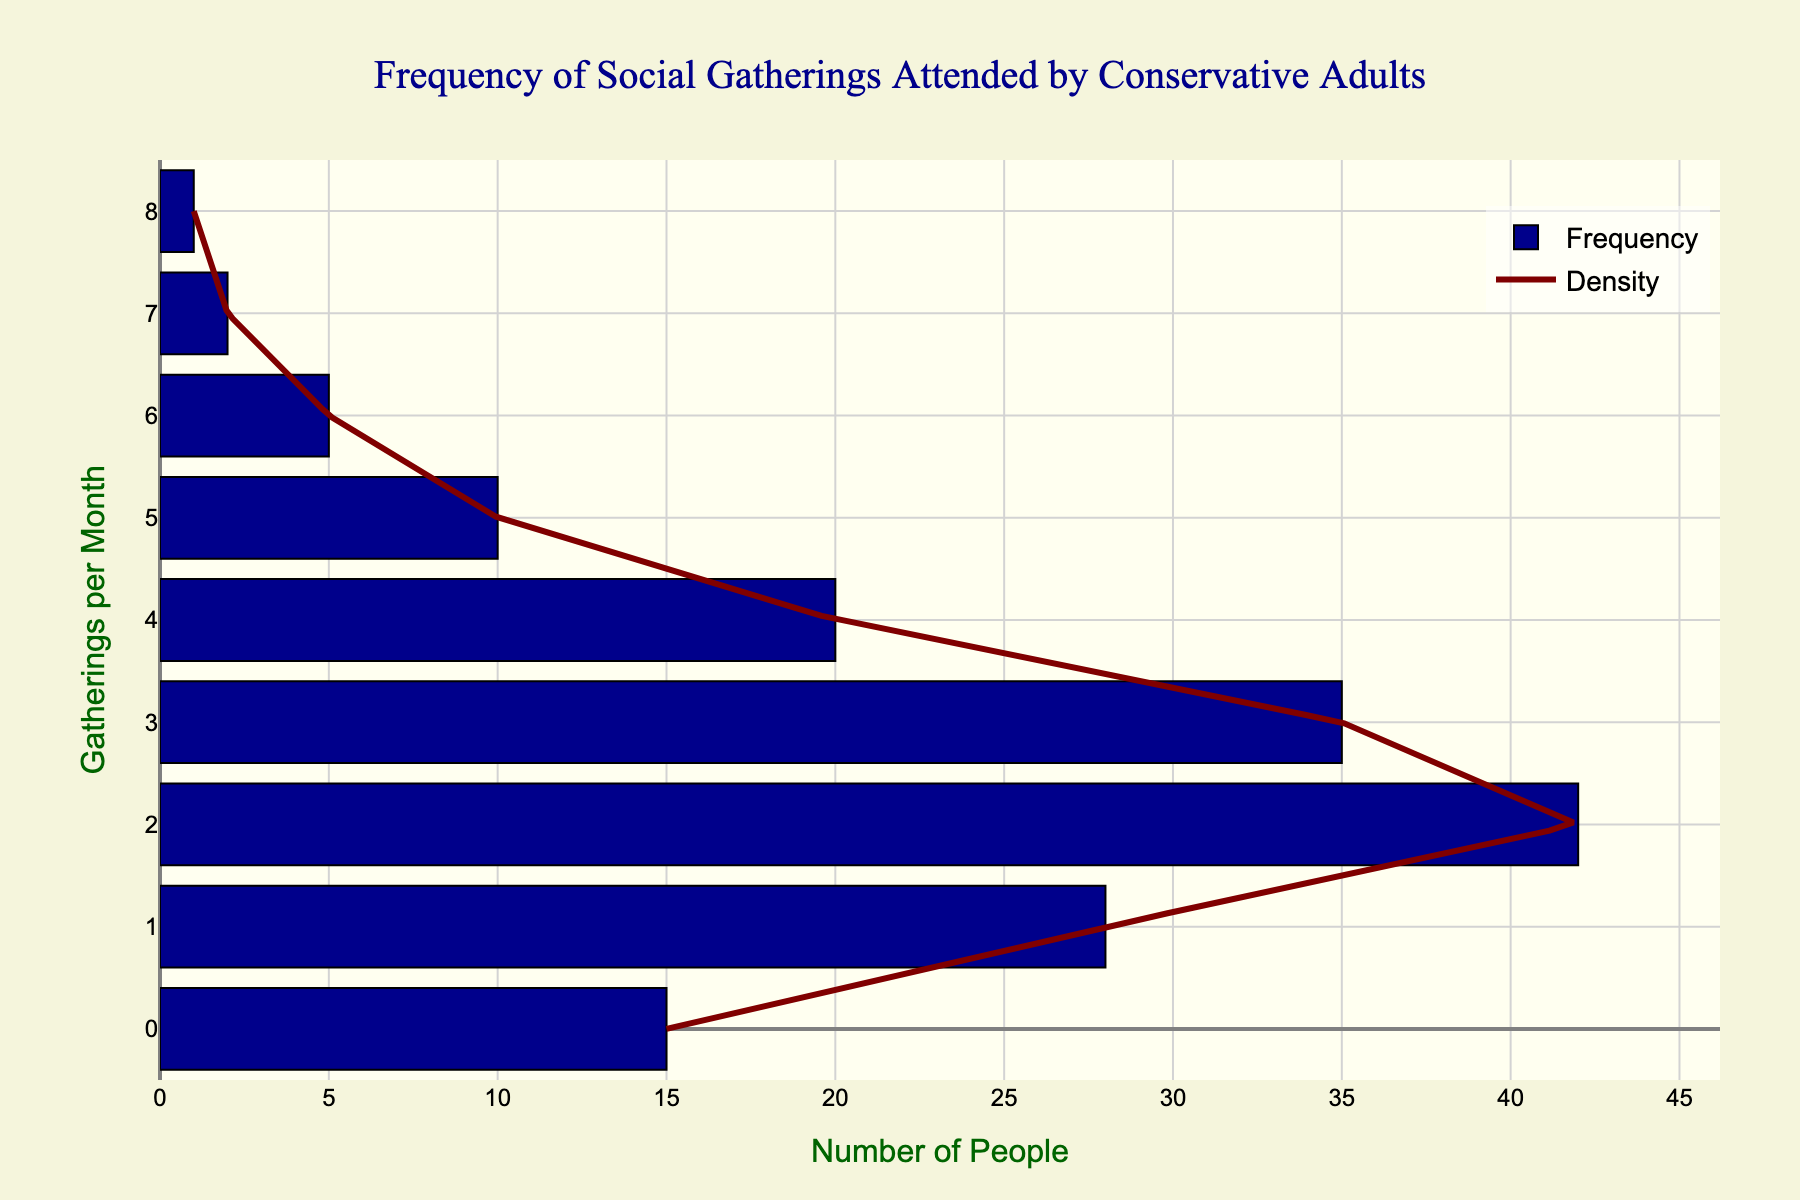What's the title of the figure? To identify the title of the figure, look at the top central part where it is typically located. The title usually provides a summary of what the figure is depicting.
Answer: Frequency of Social Gatherings Attended by Conservative Adults How many social gatherings per month are attended by the highest number of people? Identify the bar with the largest count on the horizontal axis and match it with the corresponding frequency on the vertical axis.
Answer: 2 gatherings What is the sum of people attending 0 and 1 gatherings per month? Add the counts of people attending 0 gatherings (15) and 1 gathering (28) as shown by the horizontal lengths of the bars. 15 + 28 = 43
Answer: 43 people Between attending 4 gatherings and 6 gatherings per month, which frequency has more attendees and by how much? Compare the counts for 4 gatherings (20) and 6 gatherings (5). Subtract the smaller count from the larger count: 20 - 5 = 15.
Answer: 4 gatherings by 15 people What’s the overall count of people attending more than 5 gatherings per month? Add the counts of people attending 6, 7, and 8 gatherings (5 + 2 + 1). 5 + 2 + 1 = 8.
Answer: 8 people What color represents the density curve in the figure? Identify the color of the line representing the density plot by examining the legend or the color of the curve itself.
Answer: Maroon How many people attend exactly 3 social gatherings per month? Locate the bar corresponding to 3 gatherings and read the count from the horizontal axis.
Answer: 35 people Which gatherings per month frequency shows the least dense area in the curve? Look for the part of the density curve that dips the lowest along the y-axis (frequency axis).
Answer: 7 gatherings For attendees of 2 and 3 gatherings per month, what is the total number of people combined? Sum the counts for those attending 2 gatherings (42) and 3 gatherings (35). 42 + 35 = 77.
Answer: 77 people What is the range of the vertical axis showing the number of social gatherings attended per month? Identify the minimum and maximum values displayed on the vertical axis which represent the range of the gatherings per month.
Answer: 0 to 8 